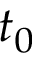<formula> <loc_0><loc_0><loc_500><loc_500>t _ { 0 }</formula> 